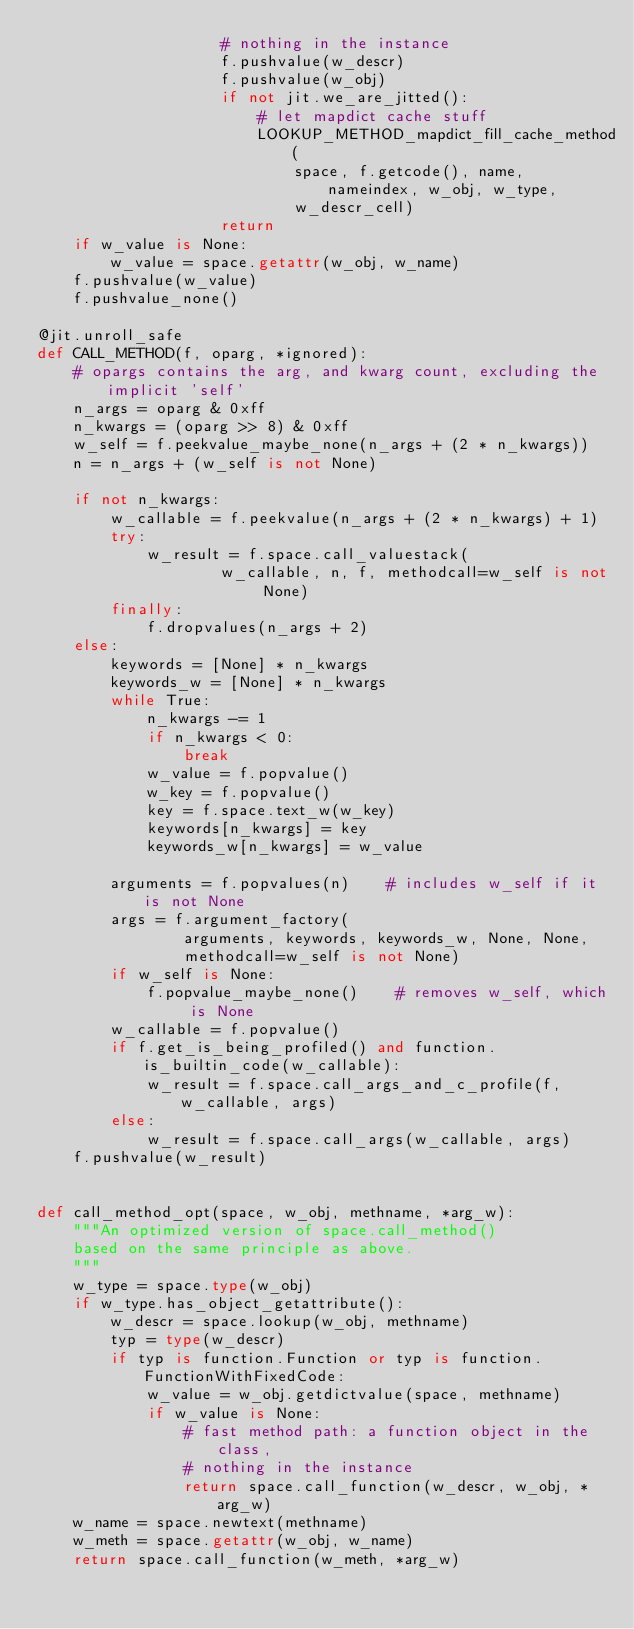Convert code to text. <code><loc_0><loc_0><loc_500><loc_500><_Python_>                    # nothing in the instance
                    f.pushvalue(w_descr)
                    f.pushvalue(w_obj)
                    if not jit.we_are_jitted():
                        # let mapdict cache stuff
                        LOOKUP_METHOD_mapdict_fill_cache_method(
                            space, f.getcode(), name, nameindex, w_obj, w_type,
                            w_descr_cell)
                    return
    if w_value is None:
        w_value = space.getattr(w_obj, w_name)
    f.pushvalue(w_value)
    f.pushvalue_none()

@jit.unroll_safe
def CALL_METHOD(f, oparg, *ignored):
    # opargs contains the arg, and kwarg count, excluding the implicit 'self'
    n_args = oparg & 0xff
    n_kwargs = (oparg >> 8) & 0xff
    w_self = f.peekvalue_maybe_none(n_args + (2 * n_kwargs))
    n = n_args + (w_self is not None)

    if not n_kwargs:
        w_callable = f.peekvalue(n_args + (2 * n_kwargs) + 1)
        try:
            w_result = f.space.call_valuestack(
                    w_callable, n, f, methodcall=w_self is not None)
        finally:
            f.dropvalues(n_args + 2)
    else:
        keywords = [None] * n_kwargs
        keywords_w = [None] * n_kwargs
        while True:
            n_kwargs -= 1
            if n_kwargs < 0:
                break
            w_value = f.popvalue()
            w_key = f.popvalue()
            key = f.space.text_w(w_key)
            keywords[n_kwargs] = key
            keywords_w[n_kwargs] = w_value

        arguments = f.popvalues(n)    # includes w_self if it is not None
        args = f.argument_factory(
                arguments, keywords, keywords_w, None, None,
                methodcall=w_self is not None)
        if w_self is None:
            f.popvalue_maybe_none()    # removes w_self, which is None
        w_callable = f.popvalue()
        if f.get_is_being_profiled() and function.is_builtin_code(w_callable):
            w_result = f.space.call_args_and_c_profile(f, w_callable, args)
        else:
            w_result = f.space.call_args(w_callable, args)
    f.pushvalue(w_result)


def call_method_opt(space, w_obj, methname, *arg_w):
    """An optimized version of space.call_method()
    based on the same principle as above.
    """
    w_type = space.type(w_obj)
    if w_type.has_object_getattribute():
        w_descr = space.lookup(w_obj, methname)
        typ = type(w_descr)
        if typ is function.Function or typ is function.FunctionWithFixedCode:
            w_value = w_obj.getdictvalue(space, methname)
            if w_value is None:
                # fast method path: a function object in the class,
                # nothing in the instance
                return space.call_function(w_descr, w_obj, *arg_w)
    w_name = space.newtext(methname)
    w_meth = space.getattr(w_obj, w_name)
    return space.call_function(w_meth, *arg_w)
</code> 